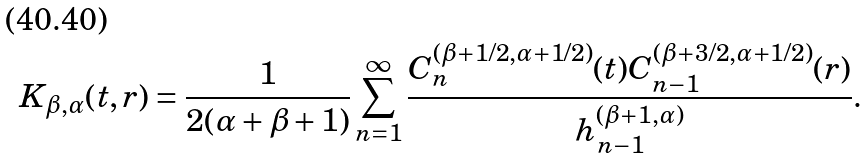<formula> <loc_0><loc_0><loc_500><loc_500>K _ { \beta , \alpha } ( t , r ) = \frac { 1 } { 2 ( \alpha + \beta + 1 ) } \sum _ { n = 1 } ^ { \infty } \frac { C _ { n } ^ { ( \beta + 1 / 2 , \alpha + 1 / 2 ) } ( t ) C _ { n - 1 } ^ { ( \beta + 3 / 2 , \alpha + 1 / 2 ) } ( r ) } { h _ { n - 1 } ^ { ( \beta + 1 , \alpha ) } } .</formula> 